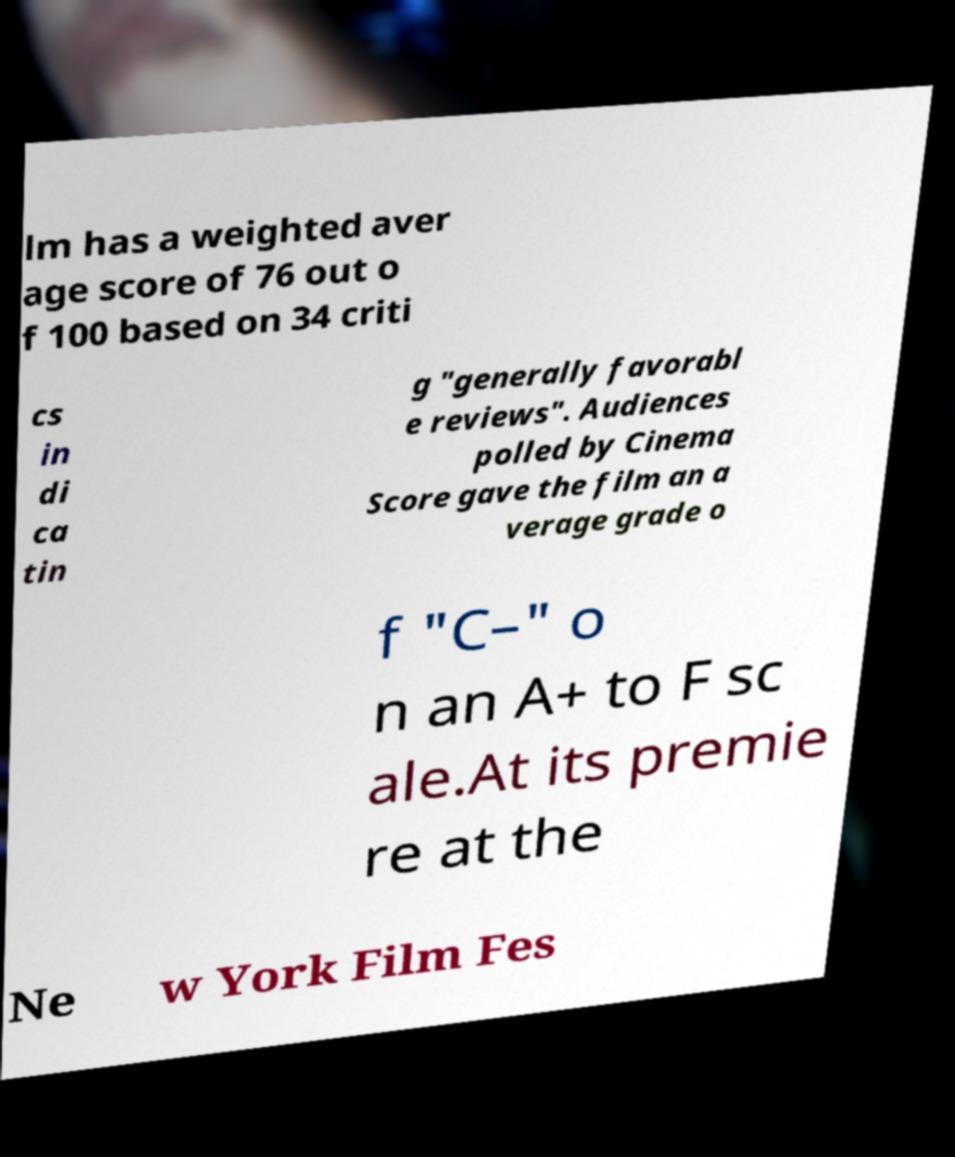Can you accurately transcribe the text from the provided image for me? lm has a weighted aver age score of 76 out o f 100 based on 34 criti cs in di ca tin g "generally favorabl e reviews". Audiences polled by Cinema Score gave the film an a verage grade o f "C–" o n an A+ to F sc ale.At its premie re at the Ne w York Film Fes 